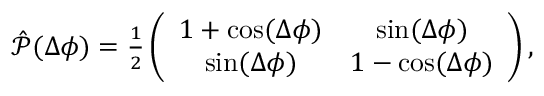<formula> <loc_0><loc_0><loc_500><loc_500>\begin{array} { r } { \hat { \mathcal { P } } ( \Delta \phi ) = \frac { 1 } { 2 } \left ( \begin{array} { c c } { 1 + \cos ( \Delta \phi ) } & { \sin ( \Delta \phi ) } \\ { \sin ( \Delta \phi ) } & { 1 - \cos ( \Delta \phi ) } \end{array} \right ) , } \end{array}</formula> 